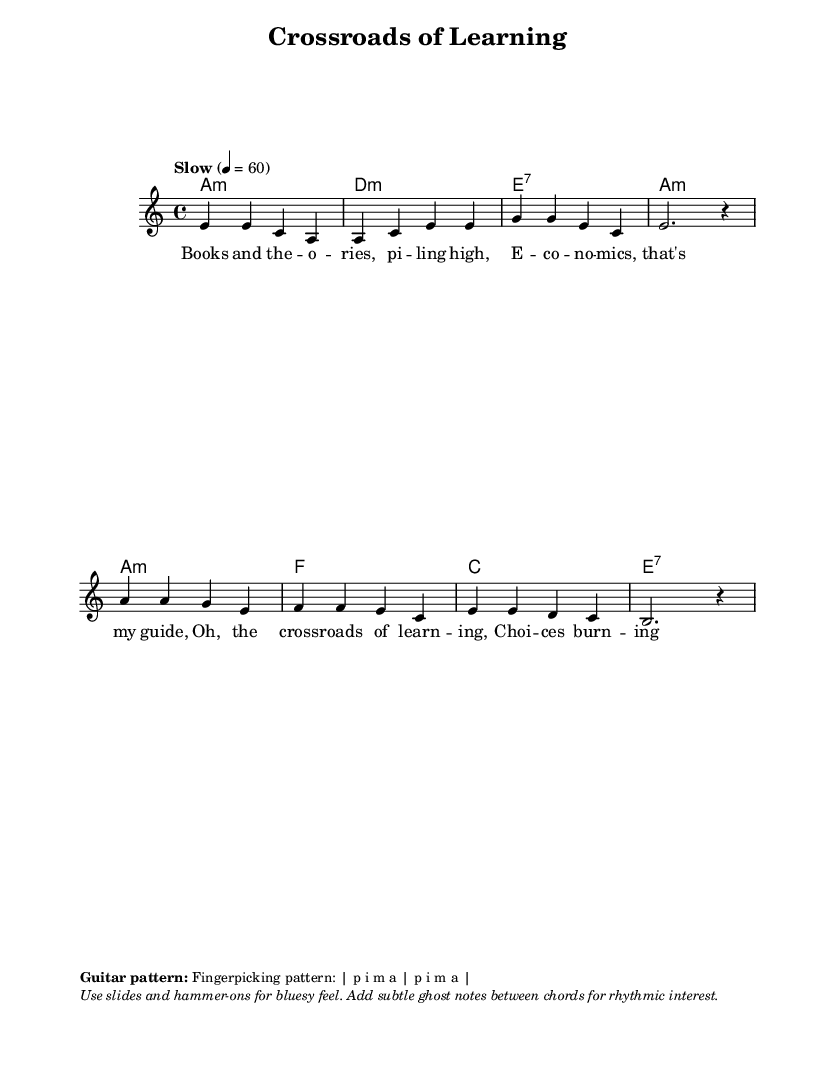What is the key signature of this music? The key signature is A minor, which contains no sharps or flats and represents the relative minor of C major. This is indicated at the beginning of the staff with the 'a' symbol.
Answer: A minor What is the time signature of this piece? The time signature is 4/4, which means there are four beats in each measure and the quarter note gets one beat. This is indicated at the start of the sheet music as '4/4'.
Answer: 4/4 What is the tempo marking for this piece? The tempo marking is "Slow," set to 60 beats per minute. This indicates the speed at which the piece should be played, and is usually noted above the staff.
Answer: Slow How many measures are in the verse section? The verse section consists of four measures. Counting the bars in the melody section reveals four distinct measures before transitioning into the chorus.
Answer: Four What chord is used at the beginning of the chorus? The chord that starts the chorus is A minor, as noted in the chord changes corresponding to the melody line. This is listed as the first chord of the chorus.
Answer: A minor What type of musical feel is indicated for this blues piece? The piece suggests using slides and hammer-ons for a bluesy feel, enhancing the expressiveness typical of this genre. This is indicated in the markup section, showing stylistic techniques for performance.
Answer: Bluesy feel 